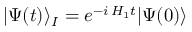<formula> <loc_0><loc_0><loc_500><loc_500>| \Psi ( t ) \rangle _ { I } = e ^ { - i \, H _ { 1 } t } | \Psi ( 0 ) \rangle</formula> 